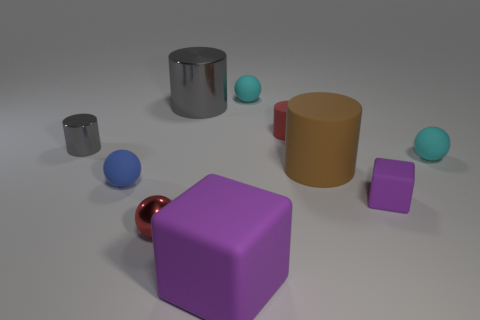Subtract 1 balls. How many balls are left? 3 Subtract all spheres. How many objects are left? 6 Add 3 big things. How many big things exist? 6 Subtract 0 purple cylinders. How many objects are left? 10 Subtract all large matte objects. Subtract all large metal cylinders. How many objects are left? 7 Add 7 big gray shiny cylinders. How many big gray shiny cylinders are left? 8 